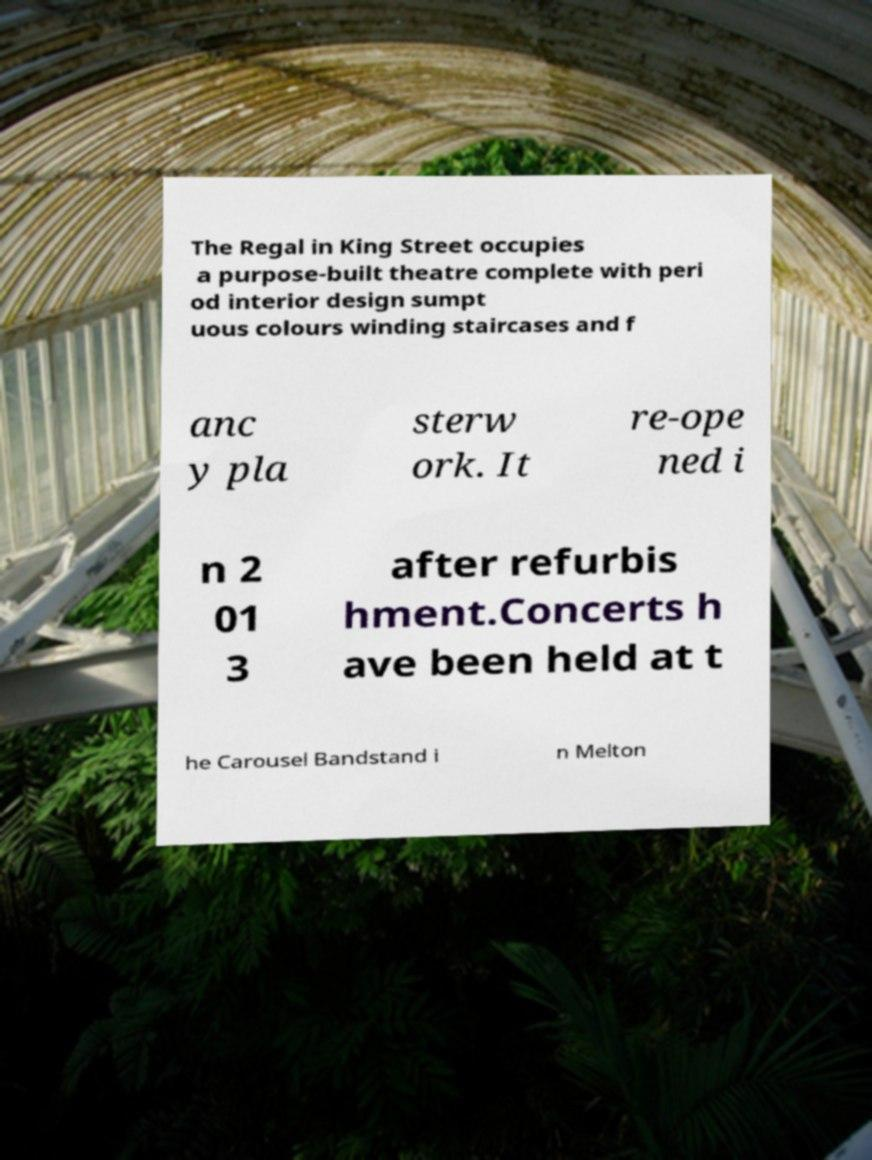There's text embedded in this image that I need extracted. Can you transcribe it verbatim? The Regal in King Street occupies a purpose-built theatre complete with peri od interior design sumpt uous colours winding staircases and f anc y pla sterw ork. It re-ope ned i n 2 01 3 after refurbis hment.Concerts h ave been held at t he Carousel Bandstand i n Melton 